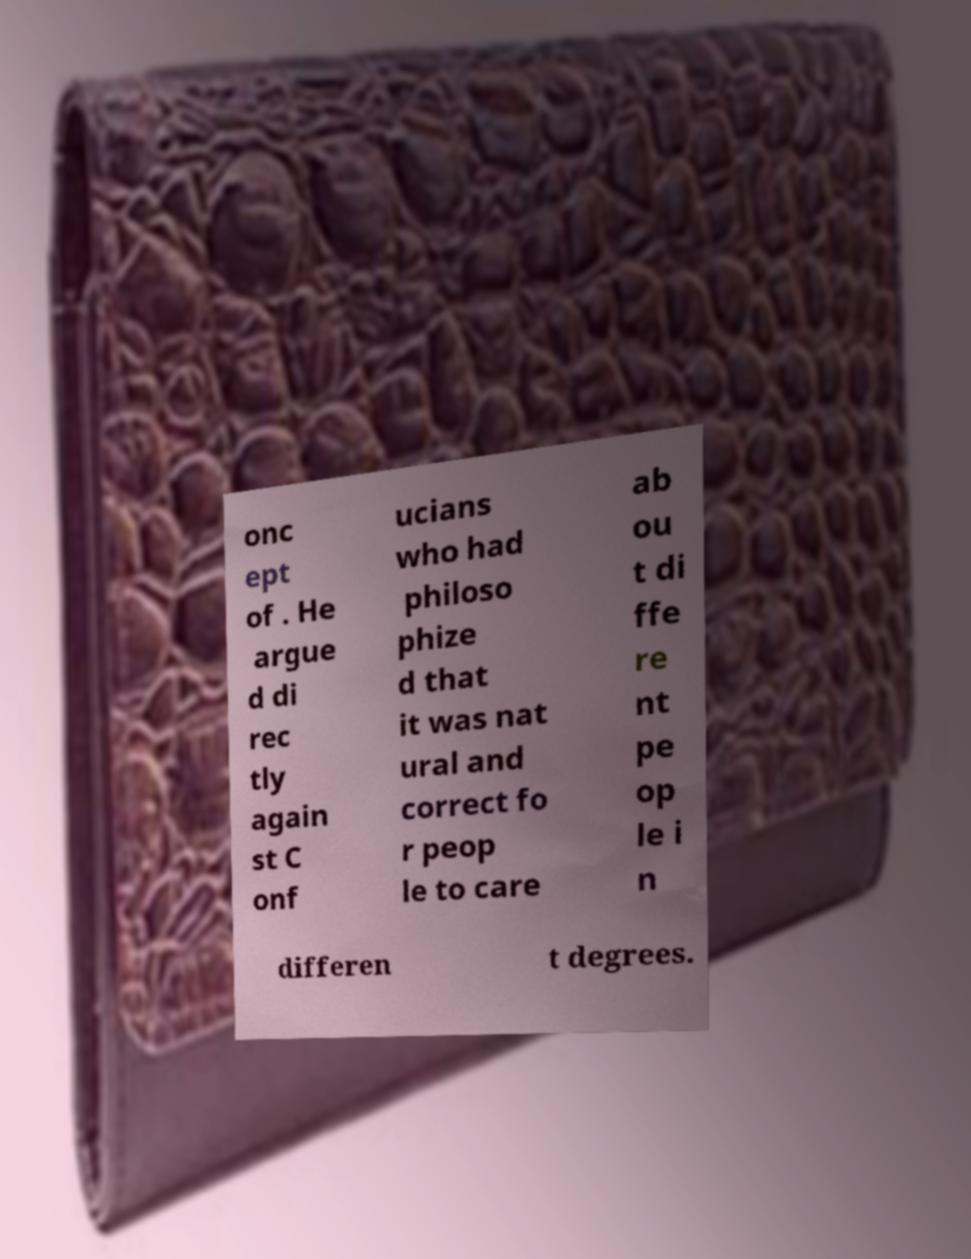Could you assist in decoding the text presented in this image and type it out clearly? onc ept of . He argue d di rec tly again st C onf ucians who had philoso phize d that it was nat ural and correct fo r peop le to care ab ou t di ffe re nt pe op le i n differen t degrees. 